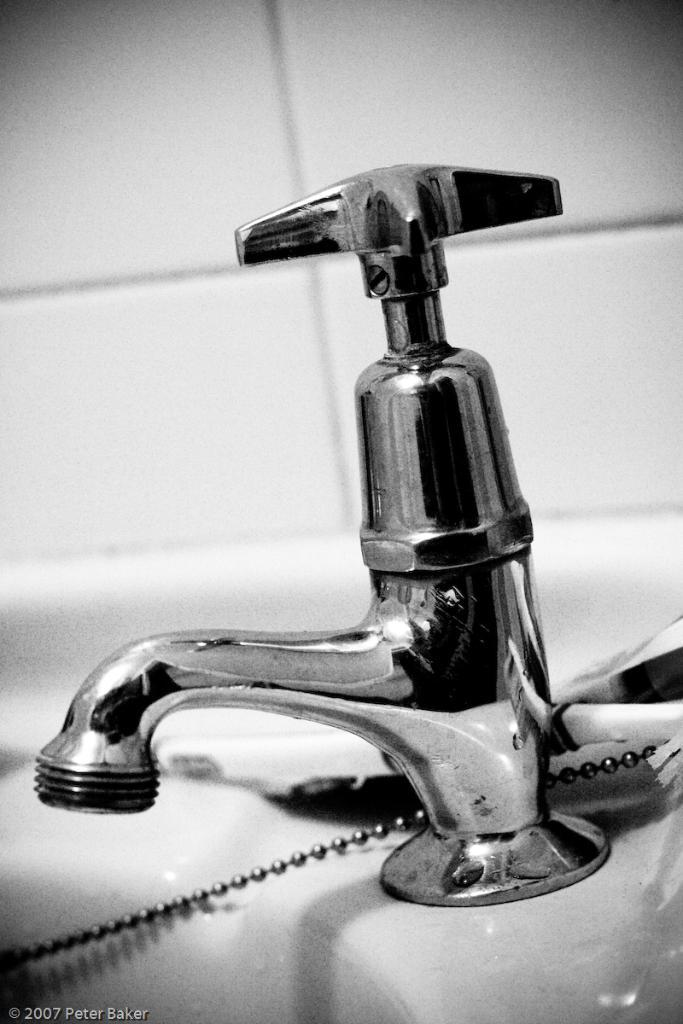What is located in the foreground of the image? There is a tap in the foreground of the image. What color is the surface on which the tap is placed? The tap is on a white surface. What is connected to the tap? There is a chain associated with the tap. What can be seen in the background of the image? There is a tile wall in the background of the image. What type of design does the secretary use in the image? There is no secretary present in the image, so it is not possible to determine the type of design they might use. 